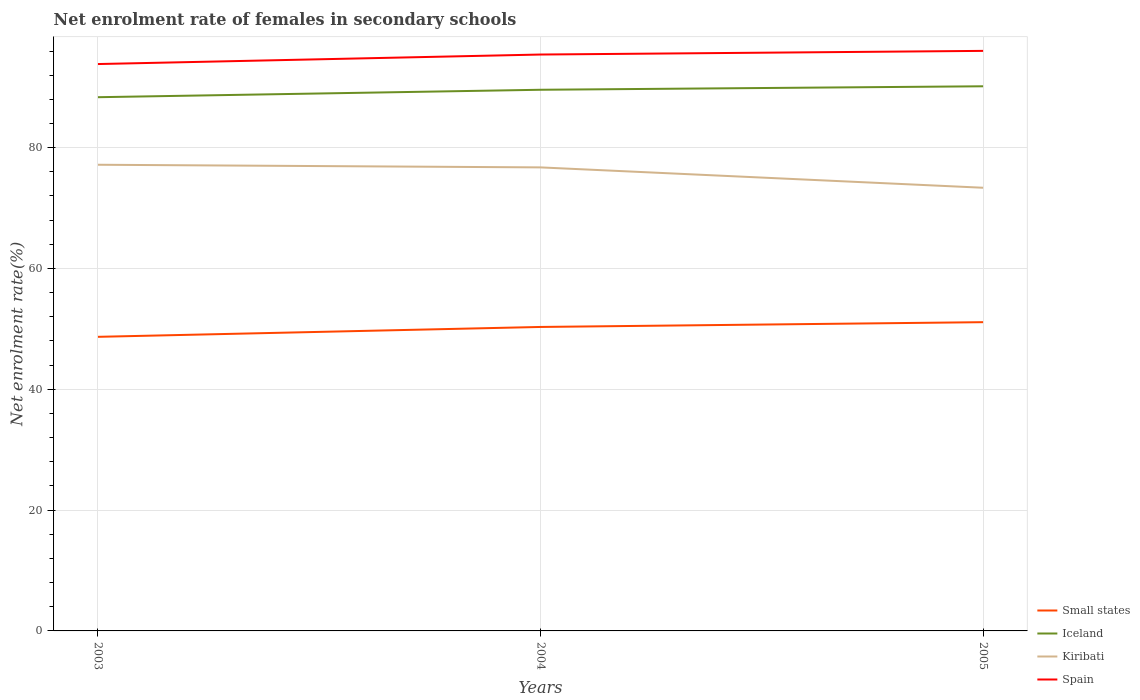Is the number of lines equal to the number of legend labels?
Your response must be concise. Yes. Across all years, what is the maximum net enrolment rate of females in secondary schools in Kiribati?
Offer a very short reply. 73.36. What is the total net enrolment rate of females in secondary schools in Iceland in the graph?
Ensure brevity in your answer.  -0.58. What is the difference between the highest and the second highest net enrolment rate of females in secondary schools in Kiribati?
Offer a very short reply. 3.81. What is the difference between the highest and the lowest net enrolment rate of females in secondary schools in Iceland?
Keep it short and to the point. 2. Does the graph contain grids?
Make the answer very short. Yes. What is the title of the graph?
Keep it short and to the point. Net enrolment rate of females in secondary schools. What is the label or title of the Y-axis?
Provide a succinct answer. Net enrolment rate(%). What is the Net enrolment rate(%) of Small states in 2003?
Make the answer very short. 48.69. What is the Net enrolment rate(%) of Iceland in 2003?
Give a very brief answer. 88.35. What is the Net enrolment rate(%) in Kiribati in 2003?
Offer a terse response. 77.17. What is the Net enrolment rate(%) of Spain in 2003?
Your answer should be compact. 93.84. What is the Net enrolment rate(%) in Small states in 2004?
Provide a short and direct response. 50.32. What is the Net enrolment rate(%) of Iceland in 2004?
Offer a terse response. 89.58. What is the Net enrolment rate(%) of Kiribati in 2004?
Your answer should be compact. 76.73. What is the Net enrolment rate(%) in Spain in 2004?
Offer a very short reply. 95.42. What is the Net enrolment rate(%) in Small states in 2005?
Ensure brevity in your answer.  51.11. What is the Net enrolment rate(%) in Iceland in 2005?
Make the answer very short. 90.16. What is the Net enrolment rate(%) of Kiribati in 2005?
Provide a succinct answer. 73.36. What is the Net enrolment rate(%) in Spain in 2005?
Give a very brief answer. 96.02. Across all years, what is the maximum Net enrolment rate(%) of Small states?
Give a very brief answer. 51.11. Across all years, what is the maximum Net enrolment rate(%) of Iceland?
Give a very brief answer. 90.16. Across all years, what is the maximum Net enrolment rate(%) of Kiribati?
Your answer should be compact. 77.17. Across all years, what is the maximum Net enrolment rate(%) of Spain?
Make the answer very short. 96.02. Across all years, what is the minimum Net enrolment rate(%) of Small states?
Your response must be concise. 48.69. Across all years, what is the minimum Net enrolment rate(%) in Iceland?
Provide a short and direct response. 88.35. Across all years, what is the minimum Net enrolment rate(%) of Kiribati?
Your answer should be very brief. 73.36. Across all years, what is the minimum Net enrolment rate(%) of Spain?
Make the answer very short. 93.84. What is the total Net enrolment rate(%) in Small states in the graph?
Keep it short and to the point. 150.12. What is the total Net enrolment rate(%) in Iceland in the graph?
Ensure brevity in your answer.  268.1. What is the total Net enrolment rate(%) of Kiribati in the graph?
Offer a very short reply. 227.27. What is the total Net enrolment rate(%) of Spain in the graph?
Offer a very short reply. 285.28. What is the difference between the Net enrolment rate(%) of Small states in 2003 and that in 2004?
Provide a succinct answer. -1.63. What is the difference between the Net enrolment rate(%) of Iceland in 2003 and that in 2004?
Provide a short and direct response. -1.23. What is the difference between the Net enrolment rate(%) of Kiribati in 2003 and that in 2004?
Provide a succinct answer. 0.44. What is the difference between the Net enrolment rate(%) of Spain in 2003 and that in 2004?
Keep it short and to the point. -1.57. What is the difference between the Net enrolment rate(%) of Small states in 2003 and that in 2005?
Provide a short and direct response. -2.43. What is the difference between the Net enrolment rate(%) of Iceland in 2003 and that in 2005?
Offer a terse response. -1.81. What is the difference between the Net enrolment rate(%) in Kiribati in 2003 and that in 2005?
Provide a succinct answer. 3.81. What is the difference between the Net enrolment rate(%) of Spain in 2003 and that in 2005?
Your response must be concise. -2.18. What is the difference between the Net enrolment rate(%) of Small states in 2004 and that in 2005?
Your answer should be compact. -0.79. What is the difference between the Net enrolment rate(%) in Iceland in 2004 and that in 2005?
Your answer should be very brief. -0.58. What is the difference between the Net enrolment rate(%) of Kiribati in 2004 and that in 2005?
Give a very brief answer. 3.37. What is the difference between the Net enrolment rate(%) in Spain in 2004 and that in 2005?
Offer a terse response. -0.61. What is the difference between the Net enrolment rate(%) in Small states in 2003 and the Net enrolment rate(%) in Iceland in 2004?
Your response must be concise. -40.9. What is the difference between the Net enrolment rate(%) of Small states in 2003 and the Net enrolment rate(%) of Kiribati in 2004?
Offer a very short reply. -28.05. What is the difference between the Net enrolment rate(%) of Small states in 2003 and the Net enrolment rate(%) of Spain in 2004?
Your answer should be very brief. -46.73. What is the difference between the Net enrolment rate(%) of Iceland in 2003 and the Net enrolment rate(%) of Kiribati in 2004?
Your response must be concise. 11.62. What is the difference between the Net enrolment rate(%) in Iceland in 2003 and the Net enrolment rate(%) in Spain in 2004?
Make the answer very short. -7.06. What is the difference between the Net enrolment rate(%) of Kiribati in 2003 and the Net enrolment rate(%) of Spain in 2004?
Provide a succinct answer. -18.24. What is the difference between the Net enrolment rate(%) in Small states in 2003 and the Net enrolment rate(%) in Iceland in 2005?
Ensure brevity in your answer.  -41.47. What is the difference between the Net enrolment rate(%) in Small states in 2003 and the Net enrolment rate(%) in Kiribati in 2005?
Give a very brief answer. -24.68. What is the difference between the Net enrolment rate(%) in Small states in 2003 and the Net enrolment rate(%) in Spain in 2005?
Ensure brevity in your answer.  -47.34. What is the difference between the Net enrolment rate(%) of Iceland in 2003 and the Net enrolment rate(%) of Kiribati in 2005?
Your answer should be very brief. 14.99. What is the difference between the Net enrolment rate(%) in Iceland in 2003 and the Net enrolment rate(%) in Spain in 2005?
Your response must be concise. -7.67. What is the difference between the Net enrolment rate(%) in Kiribati in 2003 and the Net enrolment rate(%) in Spain in 2005?
Make the answer very short. -18.85. What is the difference between the Net enrolment rate(%) in Small states in 2004 and the Net enrolment rate(%) in Iceland in 2005?
Provide a short and direct response. -39.84. What is the difference between the Net enrolment rate(%) in Small states in 2004 and the Net enrolment rate(%) in Kiribati in 2005?
Offer a very short reply. -23.04. What is the difference between the Net enrolment rate(%) of Small states in 2004 and the Net enrolment rate(%) of Spain in 2005?
Offer a very short reply. -45.7. What is the difference between the Net enrolment rate(%) in Iceland in 2004 and the Net enrolment rate(%) in Kiribati in 2005?
Offer a very short reply. 16.22. What is the difference between the Net enrolment rate(%) of Iceland in 2004 and the Net enrolment rate(%) of Spain in 2005?
Your response must be concise. -6.44. What is the difference between the Net enrolment rate(%) in Kiribati in 2004 and the Net enrolment rate(%) in Spain in 2005?
Give a very brief answer. -19.29. What is the average Net enrolment rate(%) in Small states per year?
Provide a short and direct response. 50.04. What is the average Net enrolment rate(%) in Iceland per year?
Your answer should be very brief. 89.37. What is the average Net enrolment rate(%) in Kiribati per year?
Your answer should be very brief. 75.76. What is the average Net enrolment rate(%) of Spain per year?
Give a very brief answer. 95.09. In the year 2003, what is the difference between the Net enrolment rate(%) in Small states and Net enrolment rate(%) in Iceland?
Give a very brief answer. -39.67. In the year 2003, what is the difference between the Net enrolment rate(%) in Small states and Net enrolment rate(%) in Kiribati?
Your answer should be compact. -28.48. In the year 2003, what is the difference between the Net enrolment rate(%) in Small states and Net enrolment rate(%) in Spain?
Make the answer very short. -45.16. In the year 2003, what is the difference between the Net enrolment rate(%) in Iceland and Net enrolment rate(%) in Kiribati?
Keep it short and to the point. 11.18. In the year 2003, what is the difference between the Net enrolment rate(%) of Iceland and Net enrolment rate(%) of Spain?
Provide a short and direct response. -5.49. In the year 2003, what is the difference between the Net enrolment rate(%) of Kiribati and Net enrolment rate(%) of Spain?
Your answer should be very brief. -16.67. In the year 2004, what is the difference between the Net enrolment rate(%) of Small states and Net enrolment rate(%) of Iceland?
Provide a succinct answer. -39.27. In the year 2004, what is the difference between the Net enrolment rate(%) of Small states and Net enrolment rate(%) of Kiribati?
Your response must be concise. -26.41. In the year 2004, what is the difference between the Net enrolment rate(%) in Small states and Net enrolment rate(%) in Spain?
Your response must be concise. -45.1. In the year 2004, what is the difference between the Net enrolment rate(%) of Iceland and Net enrolment rate(%) of Kiribati?
Your response must be concise. 12.85. In the year 2004, what is the difference between the Net enrolment rate(%) in Iceland and Net enrolment rate(%) in Spain?
Your answer should be compact. -5.83. In the year 2004, what is the difference between the Net enrolment rate(%) of Kiribati and Net enrolment rate(%) of Spain?
Your answer should be very brief. -18.68. In the year 2005, what is the difference between the Net enrolment rate(%) of Small states and Net enrolment rate(%) of Iceland?
Your answer should be compact. -39.05. In the year 2005, what is the difference between the Net enrolment rate(%) of Small states and Net enrolment rate(%) of Kiribati?
Ensure brevity in your answer.  -22.25. In the year 2005, what is the difference between the Net enrolment rate(%) in Small states and Net enrolment rate(%) in Spain?
Provide a short and direct response. -44.91. In the year 2005, what is the difference between the Net enrolment rate(%) in Iceland and Net enrolment rate(%) in Kiribati?
Provide a succinct answer. 16.8. In the year 2005, what is the difference between the Net enrolment rate(%) in Iceland and Net enrolment rate(%) in Spain?
Provide a succinct answer. -5.86. In the year 2005, what is the difference between the Net enrolment rate(%) of Kiribati and Net enrolment rate(%) of Spain?
Provide a succinct answer. -22.66. What is the ratio of the Net enrolment rate(%) in Small states in 2003 to that in 2004?
Offer a terse response. 0.97. What is the ratio of the Net enrolment rate(%) in Iceland in 2003 to that in 2004?
Your answer should be compact. 0.99. What is the ratio of the Net enrolment rate(%) of Spain in 2003 to that in 2004?
Your answer should be compact. 0.98. What is the ratio of the Net enrolment rate(%) in Small states in 2003 to that in 2005?
Ensure brevity in your answer.  0.95. What is the ratio of the Net enrolment rate(%) of Kiribati in 2003 to that in 2005?
Your response must be concise. 1.05. What is the ratio of the Net enrolment rate(%) of Spain in 2003 to that in 2005?
Keep it short and to the point. 0.98. What is the ratio of the Net enrolment rate(%) of Small states in 2004 to that in 2005?
Your answer should be compact. 0.98. What is the ratio of the Net enrolment rate(%) in Iceland in 2004 to that in 2005?
Offer a terse response. 0.99. What is the ratio of the Net enrolment rate(%) of Kiribati in 2004 to that in 2005?
Give a very brief answer. 1.05. What is the difference between the highest and the second highest Net enrolment rate(%) in Small states?
Offer a very short reply. 0.79. What is the difference between the highest and the second highest Net enrolment rate(%) in Iceland?
Ensure brevity in your answer.  0.58. What is the difference between the highest and the second highest Net enrolment rate(%) in Kiribati?
Ensure brevity in your answer.  0.44. What is the difference between the highest and the second highest Net enrolment rate(%) of Spain?
Your response must be concise. 0.61. What is the difference between the highest and the lowest Net enrolment rate(%) of Small states?
Make the answer very short. 2.43. What is the difference between the highest and the lowest Net enrolment rate(%) of Iceland?
Give a very brief answer. 1.81. What is the difference between the highest and the lowest Net enrolment rate(%) of Kiribati?
Offer a very short reply. 3.81. What is the difference between the highest and the lowest Net enrolment rate(%) in Spain?
Make the answer very short. 2.18. 